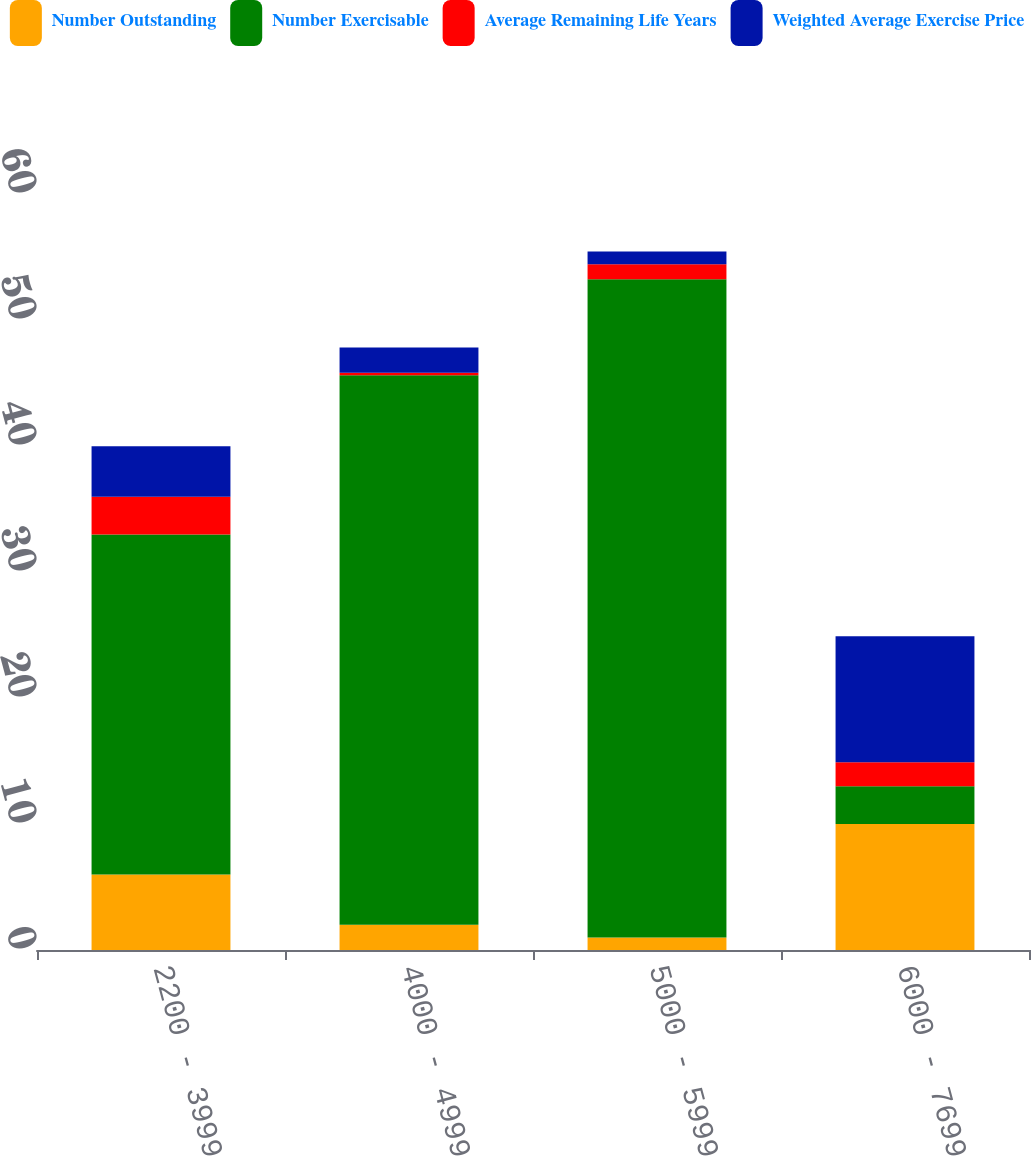Convert chart. <chart><loc_0><loc_0><loc_500><loc_500><stacked_bar_chart><ecel><fcel>2200 - 3999<fcel>4000 - 4999<fcel>5000 - 5999<fcel>6000 - 7699<nl><fcel>Number Outstanding<fcel>6<fcel>2<fcel>1<fcel>10<nl><fcel>Number Exercisable<fcel>26.98<fcel>43.62<fcel>52.23<fcel>3<nl><fcel>Average Remaining Life Years<fcel>3<fcel>0.2<fcel>1.2<fcel>1.9<nl><fcel>Weighted Average Exercise Price<fcel>4<fcel>2<fcel>1<fcel>10<nl></chart> 